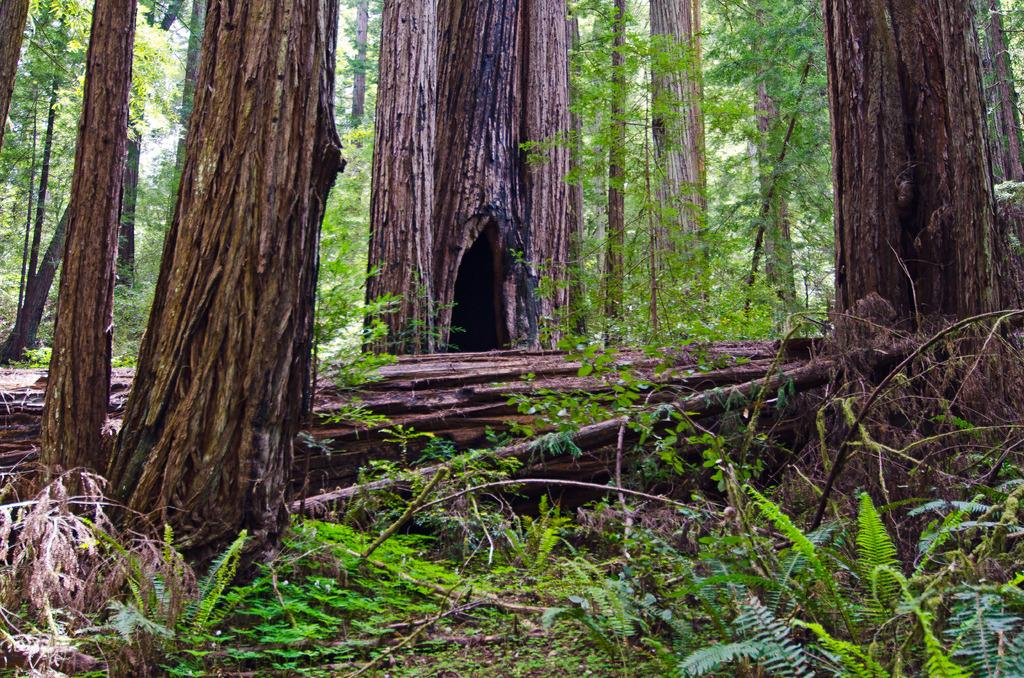What type of environment is depicted in the image? The image appears to be taken in a forest. What can be seen among the trees in the image? There is a group of trees in the image. What type of vegetation is present at the bottom of the image? Grass and plants are present at the bottom of the image. What type of cloth is draped over the pot in the image? There is no pot or cloth present in the image; it depicts a forest setting with trees, grass, and plants. 